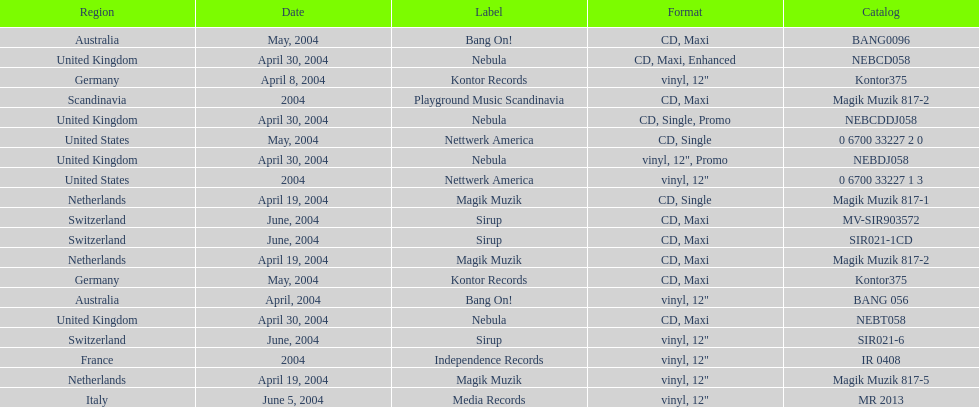What label was italy on? Media Records. 